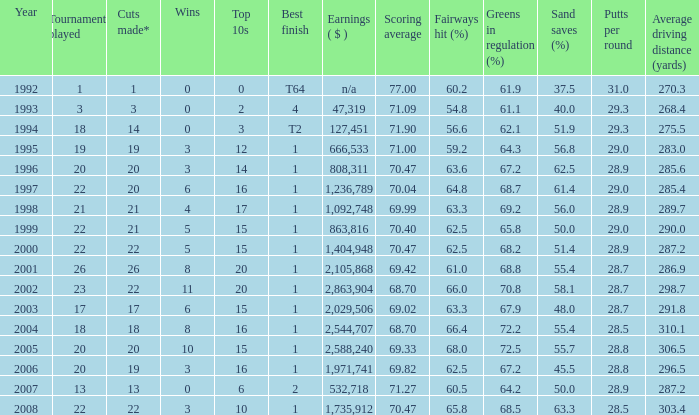Tell me the highest wins for year less than 2000 and best finish of 4 and tournaments played less than 3 None. 